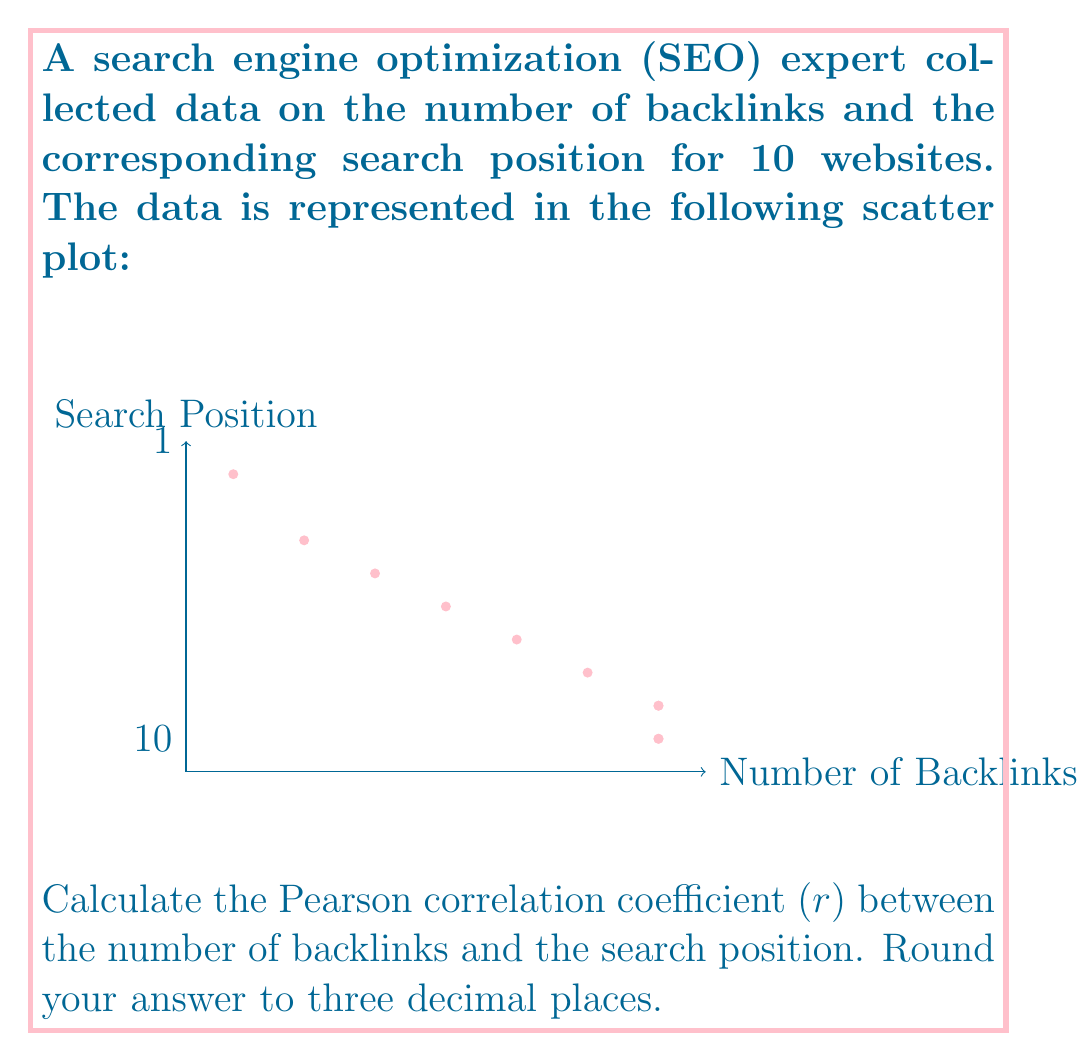Teach me how to tackle this problem. To calculate the Pearson correlation coefficient, we'll use the formula:

$$ r = \frac{n\sum xy - \sum x \sum y}{\sqrt{[n\sum x^2 - (\sum x)^2][n\sum y^2 - (\sum y)^2]}} $$

Where:
$n$ = number of data points
$x$ = number of backlinks
$y$ = search position

Step 1: Calculate the necessary sums:
$n = 10$
$\sum x = 775$
$\sum y = 40$
$\sum xy = 2275$
$\sum x^2 = 79,625$
$\sum y^2 = 238$

Step 2: Apply the formula:

$$ r = \frac{10(2275) - (775)(40)}{\sqrt{[10(79,625) - (775)^2][10(238) - (40)^2]}} $$

Step 3: Simplify:

$$ r = \frac{22,750 - 31,000}{\sqrt{(796,250 - 600,625)(2,380 - 1,600)}} $$

$$ r = \frac{-8,250}{\sqrt{(195,625)(780)}} $$

$$ r = \frac{-8,250}{\sqrt{152,587,500}} $$

$$ r = \frac{-8,250}{12,352.63} $$

$$ r = -0.667869 $$

Step 4: Round to three decimal places:

$r = -0.668$

The negative value indicates a strong negative correlation between the number of backlinks and search position, meaning that as the number of backlinks increases, the search position tends to improve (lower numbers indicate better positions).
Answer: $r = -0.668$ 